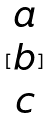<formula> <loc_0><loc_0><loc_500><loc_500>[ \begin{matrix} a \\ b \\ c \end{matrix} ]</formula> 